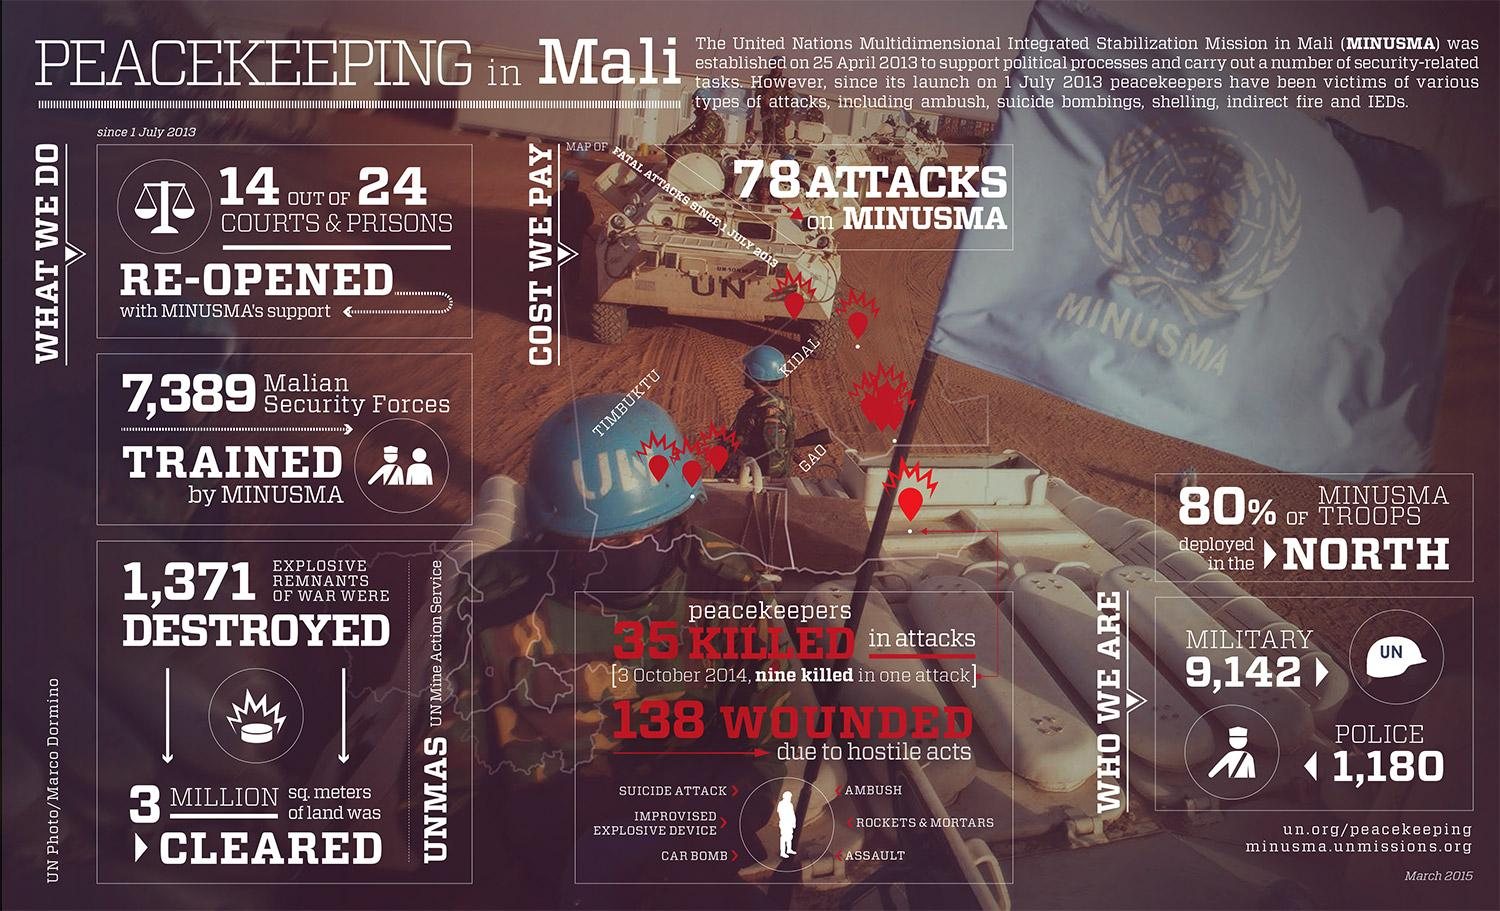Point out several critical features in this image. Since July 1, 2013, there have been 78 attacks targeted at MINUSMA. The United Nations deployed 1,180 police personnel for the MINUSMA mission. According to the information, approximately 80% of the MINUSMA troops were deployed in the North. The United Nations has deployed 9,142 military troops for the MINUSMA mission. The United Nations Mine Action Service (UNMAS) successfully destroyed 1,371 explosive remnants of war in its efforts to promote peace and security. 